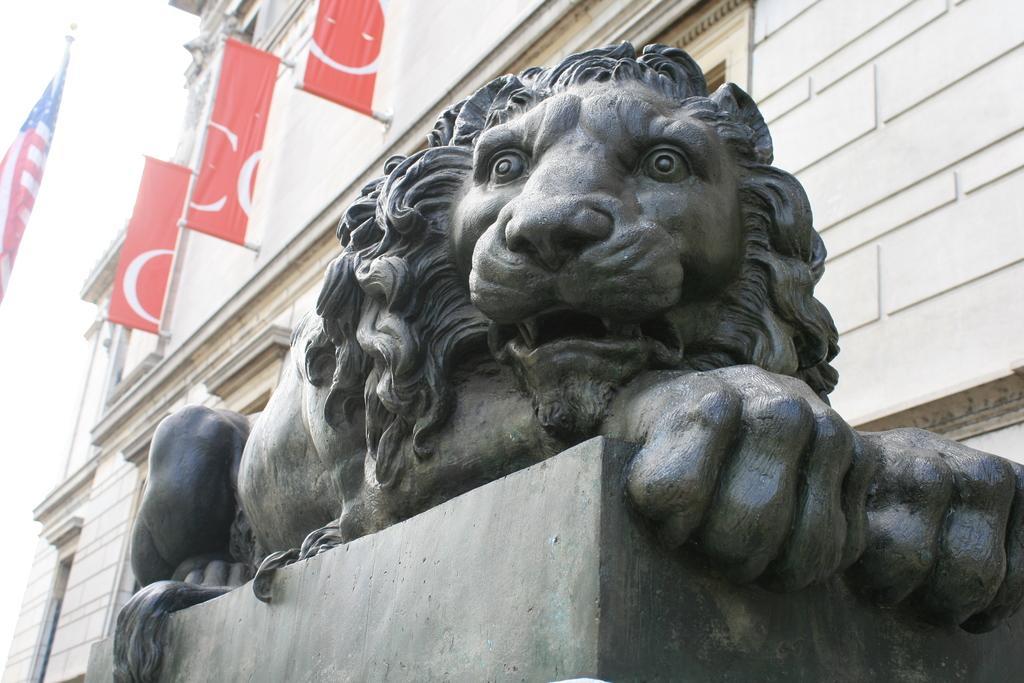Please provide a concise description of this image. In this image we can see a statue, pedestal, buildings, flags and sky. 